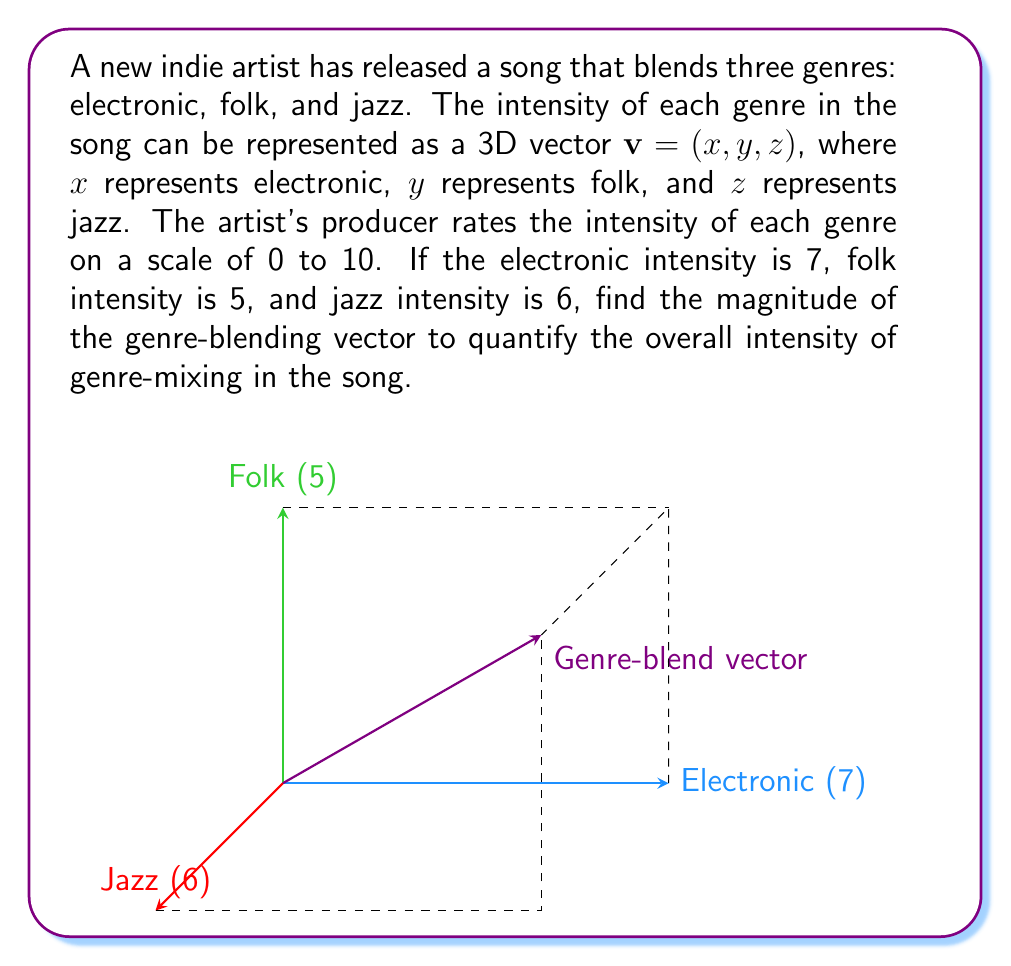Could you help me with this problem? To find the magnitude of the genre-blending vector, we need to calculate the length of the 3D vector $\mathbf{v} = (7, 5, 6)$. The magnitude of a vector is given by the square root of the sum of the squares of its components.

Let's follow these steps:

1) The formula for the magnitude of a 3D vector $\mathbf{v} = (x, y, z)$ is:

   $$\|\mathbf{v}\| = \sqrt{x^2 + y^2 + z^2}$$

2) Substitute the values into the formula:

   $$\|\mathbf{v}\| = \sqrt{7^2 + 5^2 + 6^2}$$

3) Calculate the squares:

   $$\|\mathbf{v}\| = \sqrt{49 + 25 + 36}$$

4) Sum the values under the square root:

   $$\|\mathbf{v}\| = \sqrt{110}$$

5) Simplify the square root:

   $$\|\mathbf{v}\| = \sqrt{110} \approx 10.488$$

The magnitude of the genre-blending vector is approximately 10.488, which represents the overall intensity of genre-mixing in the song.
Answer: $\sqrt{110} \approx 10.488$ 